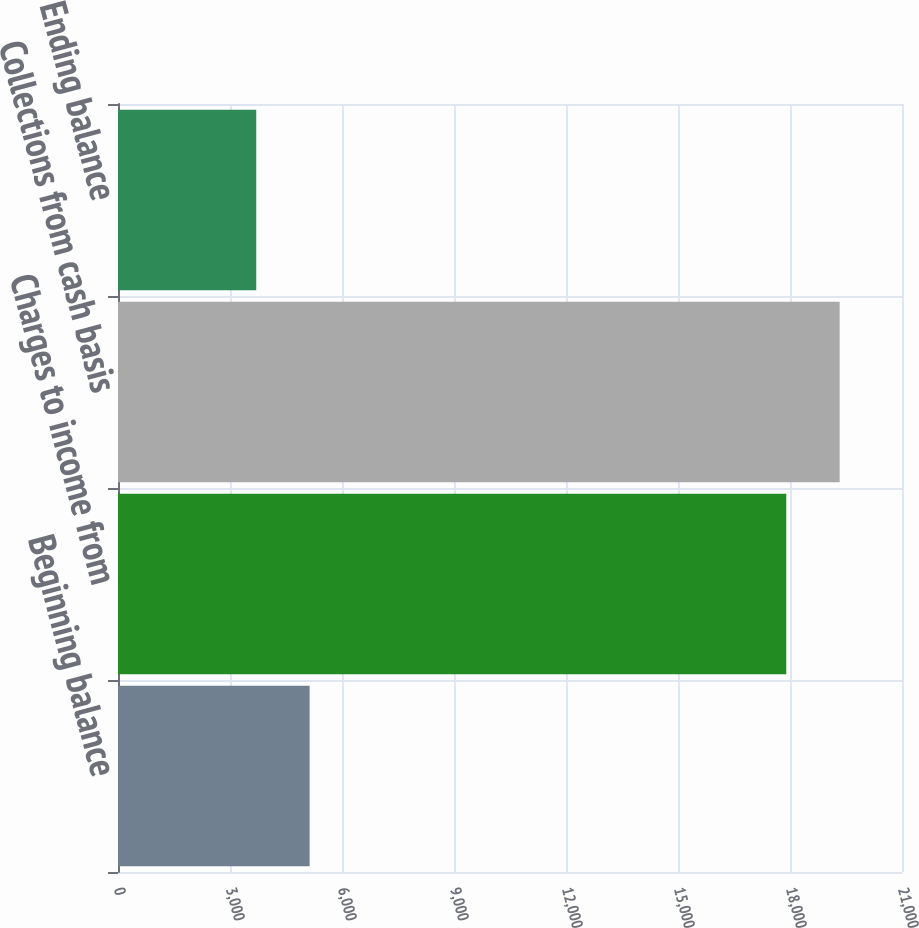<chart> <loc_0><loc_0><loc_500><loc_500><bar_chart><fcel>Beginning balance<fcel>Charges to income from<fcel>Collections from cash basis<fcel>Ending balance<nl><fcel>5133.1<fcel>17900<fcel>19330.1<fcel>3703<nl></chart> 